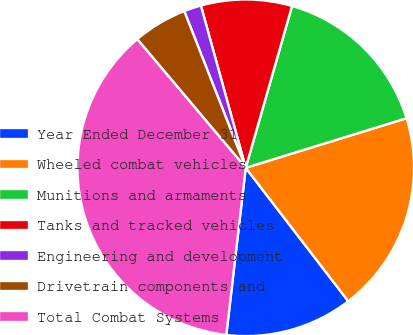Convert chart to OTSL. <chart><loc_0><loc_0><loc_500><loc_500><pie_chart><fcel>Year Ended December 31<fcel>Wheeled combat vehicles<fcel>Munitions and armaments<fcel>Tanks and tracked vehicles<fcel>Engineering and development<fcel>Drivetrain components and<fcel>Total Combat Systems<nl><fcel>12.27%<fcel>19.33%<fcel>15.8%<fcel>8.73%<fcel>1.66%<fcel>5.2%<fcel>37.0%<nl></chart> 